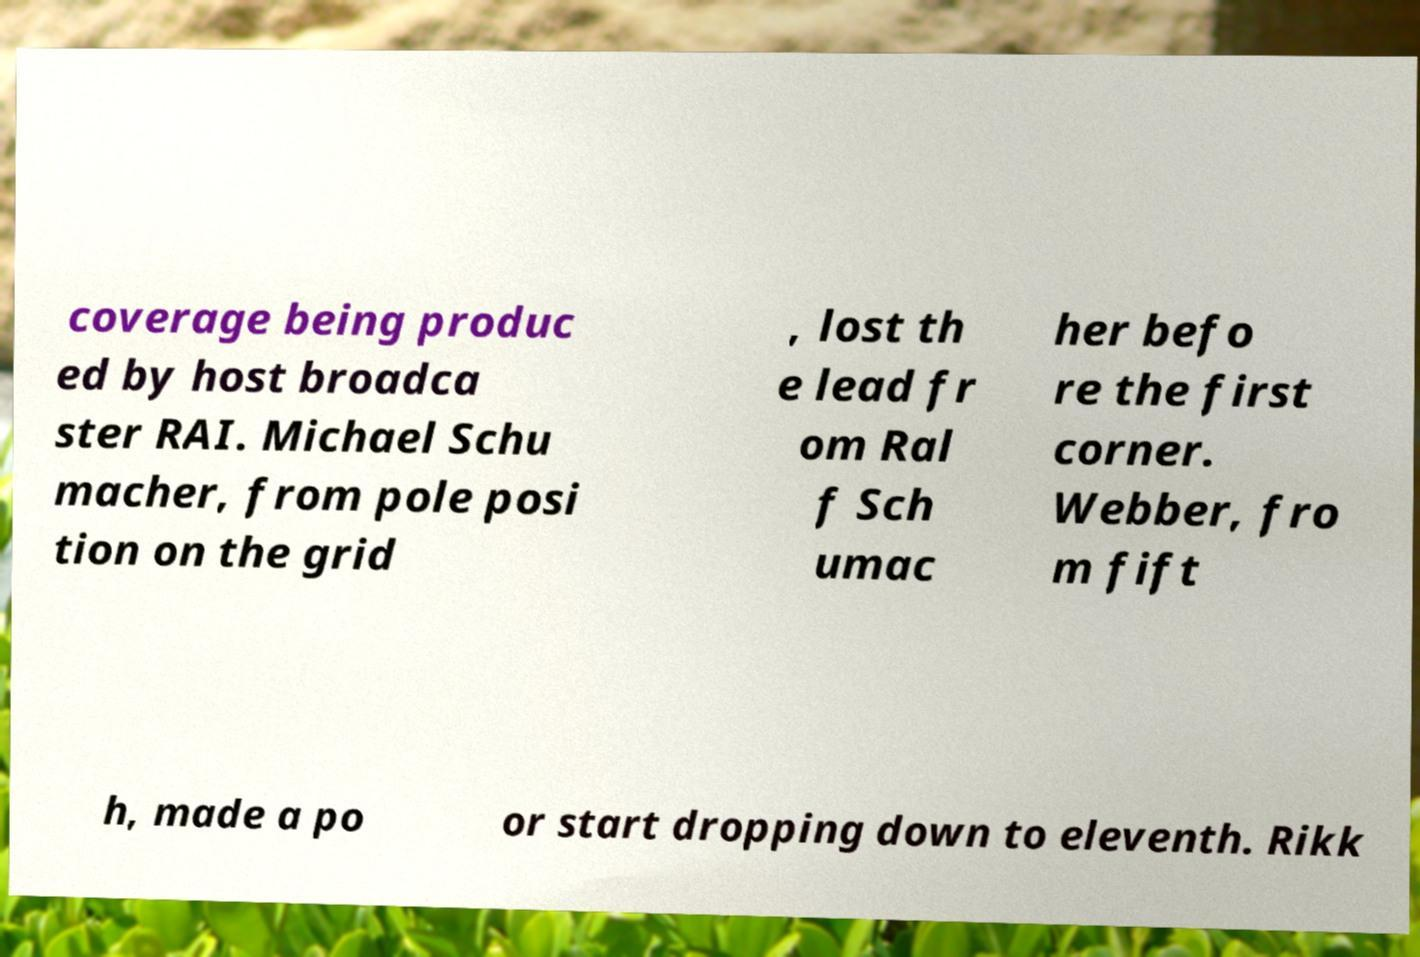Could you assist in decoding the text presented in this image and type it out clearly? coverage being produc ed by host broadca ster RAI. Michael Schu macher, from pole posi tion on the grid , lost th e lead fr om Ral f Sch umac her befo re the first corner. Webber, fro m fift h, made a po or start dropping down to eleventh. Rikk 